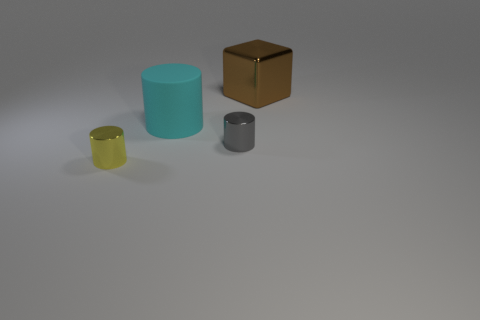Add 4 purple matte things. How many objects exist? 8 Subtract all cubes. How many objects are left? 3 Subtract all purple matte cubes. Subtract all large brown shiny objects. How many objects are left? 3 Add 2 big metal cubes. How many big metal cubes are left? 3 Add 4 things. How many things exist? 8 Subtract 0 green spheres. How many objects are left? 4 